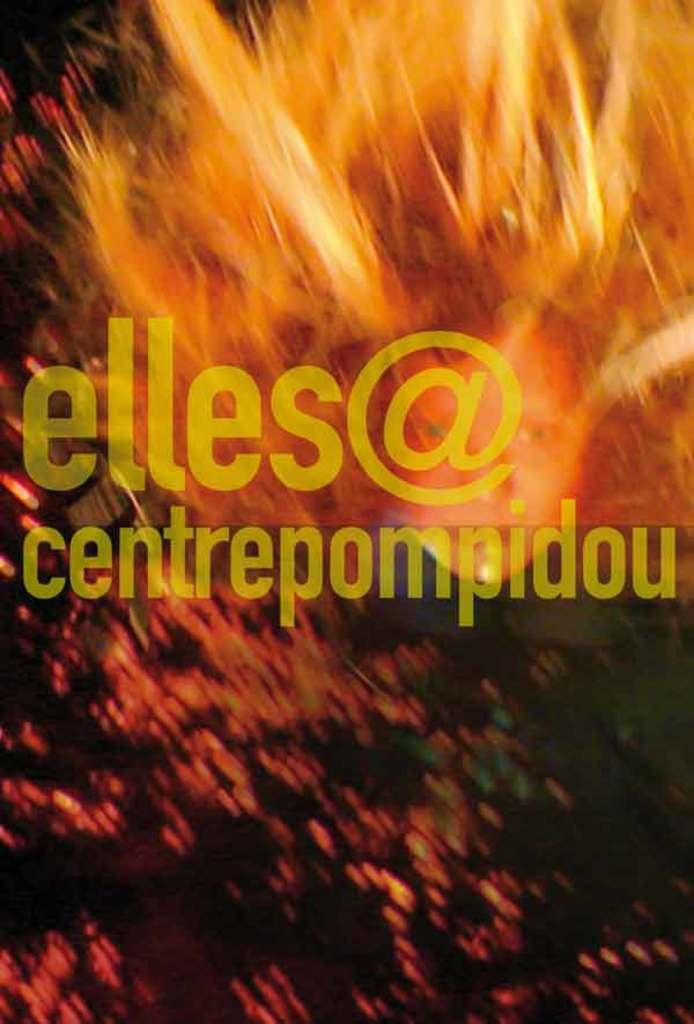<image>
Describe the image concisely. A blurry image of a red haired person displays the yellow faded text "elles@centrepompidou" in the foreground. 